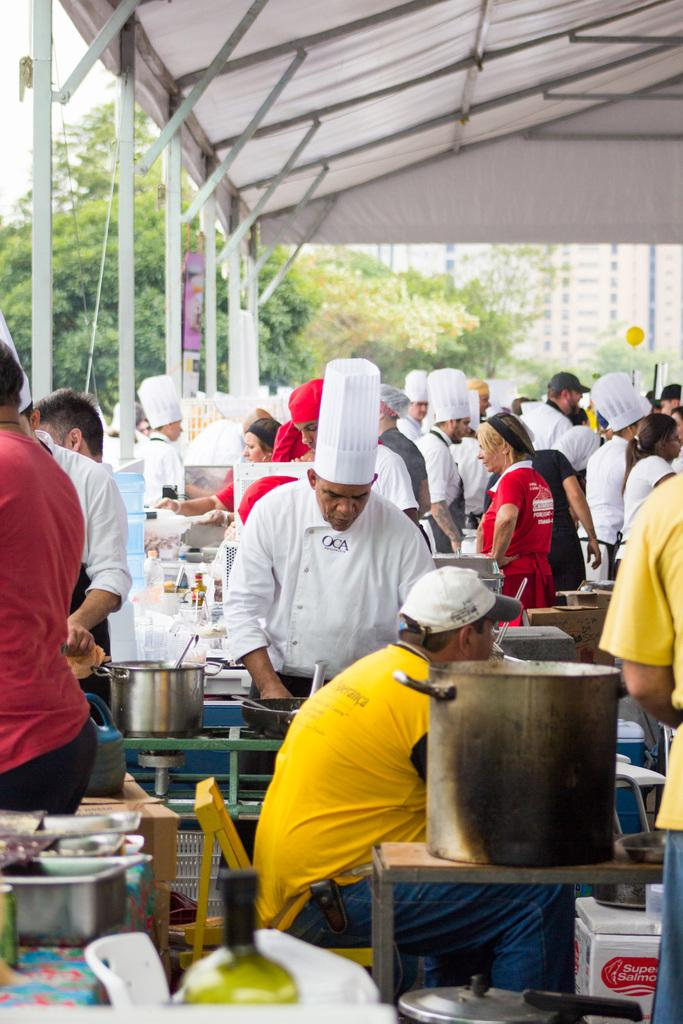What type of structure is visible in the image? There is a tent in the image. What can be seen inside the tent? There are groups of people in the tent. What objects are present in the image? There is a cloth, a bottle, a bowl, spoons, chairs, and a building visible in the image. What is the natural environment like in the image? There are trees in the image, and the sky is visible. What arithmetic problem is being solved on the door in the image? There is no door present in the image, and no arithmetic problem is being solved. 